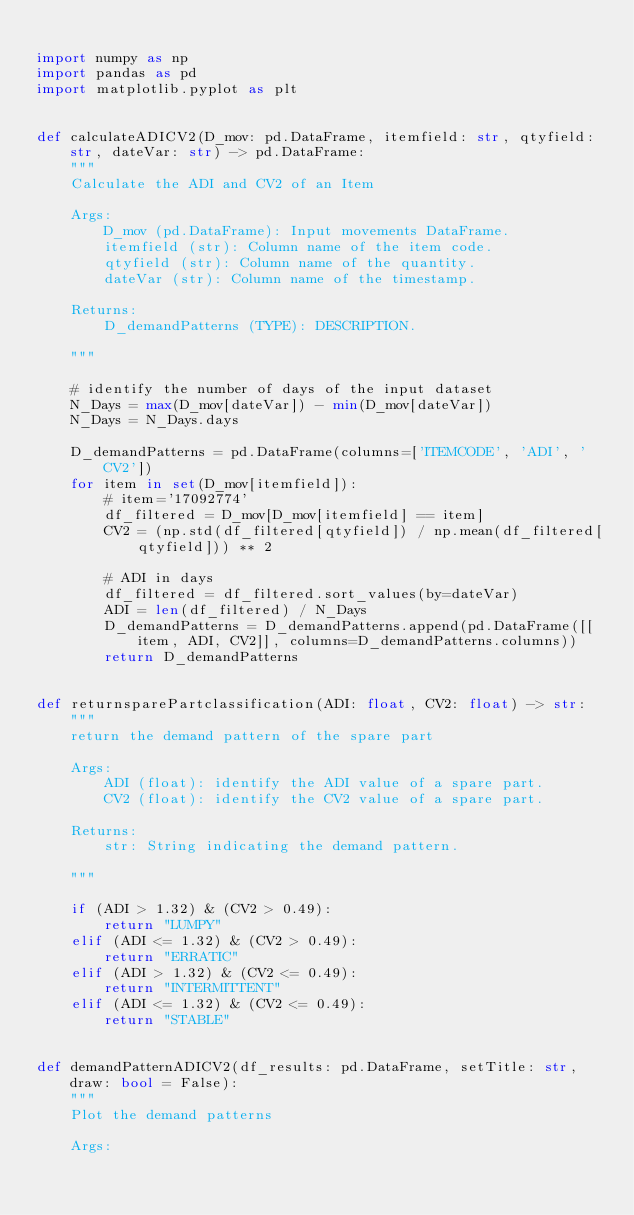Convert code to text. <code><loc_0><loc_0><loc_500><loc_500><_Python_>
import numpy as np
import pandas as pd
import matplotlib.pyplot as plt


def calculateADICV2(D_mov: pd.DataFrame, itemfield: str, qtyfield: str, dateVar: str) -> pd.DataFrame:
    """
    Calculate the ADI and CV2 of an Item

    Args:
        D_mov (pd.DataFrame): Input movements DataFrame.
        itemfield (str): Column name of the item code.
        qtyfield (str): Column name of the quantity.
        dateVar (str): Column name of the timestamp.

    Returns:
        D_demandPatterns (TYPE): DESCRIPTION.

    """

    # identify the number of days of the input dataset
    N_Days = max(D_mov[dateVar]) - min(D_mov[dateVar])
    N_Days = N_Days.days

    D_demandPatterns = pd.DataFrame(columns=['ITEMCODE', 'ADI', 'CV2'])
    for item in set(D_mov[itemfield]):
        # item='17092774'
        df_filtered = D_mov[D_mov[itemfield] == item]
        CV2 = (np.std(df_filtered[qtyfield]) / np.mean(df_filtered[qtyfield])) ** 2

        # ADI in days
        df_filtered = df_filtered.sort_values(by=dateVar)
        ADI = len(df_filtered) / N_Days
        D_demandPatterns = D_demandPatterns.append(pd.DataFrame([[item, ADI, CV2]], columns=D_demandPatterns.columns))
        return D_demandPatterns


def returnsparePartclassification(ADI: float, CV2: float) -> str:
    """
    return the demand pattern of the spare part

    Args:
        ADI (float): identify the ADI value of a spare part.
        CV2 (float): identify the CV2 value of a spare part.

    Returns:
        str: String indicating the demand pattern.

    """

    if (ADI > 1.32) & (CV2 > 0.49):
        return "LUMPY"
    elif (ADI <= 1.32) & (CV2 > 0.49):
        return "ERRATIC"
    elif (ADI > 1.32) & (CV2 <= 0.49):
        return "INTERMITTENT"
    elif (ADI <= 1.32) & (CV2 <= 0.49):
        return "STABLE"


def demandPatternADICV2(df_results: pd.DataFrame, setTitle: str, draw: bool = False):
    """
    Plot the demand patterns

    Args:</code> 